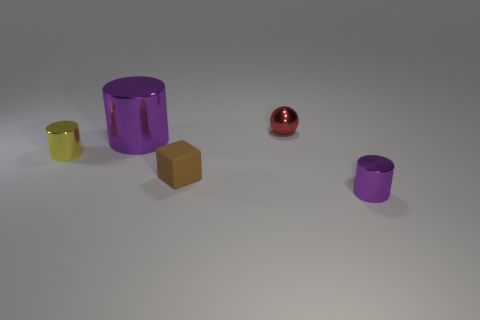Subtract all purple cylinders. How many were subtracted if there are1purple cylinders left? 1 Subtract all gray cubes. How many purple cylinders are left? 2 Subtract all yellow cylinders. How many cylinders are left? 2 Add 1 large shiny objects. How many objects exist? 6 Subtract 1 cylinders. How many cylinders are left? 2 Subtract all gray cylinders. Subtract all cyan spheres. How many cylinders are left? 3 Subtract all cylinders. How many objects are left? 2 Subtract all blocks. Subtract all small brown cubes. How many objects are left? 3 Add 4 yellow objects. How many yellow objects are left? 5 Add 3 large gray rubber blocks. How many large gray rubber blocks exist? 3 